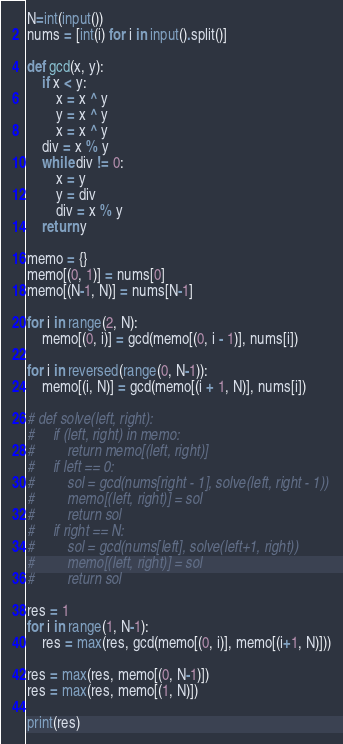Convert code to text. <code><loc_0><loc_0><loc_500><loc_500><_Python_>N=int(input())
nums = [int(i) for i in input().split()]

def gcd(x, y):
    if x < y:
        x = x ^ y
        y = x ^ y
        x = x ^ y
    div = x % y
    while div != 0:
        x = y
        y = div
        div = x % y
    return y

memo = {}
memo[(0, 1)] = nums[0]
memo[(N-1, N)] = nums[N-1]

for i in range(2, N):
    memo[(0, i)] = gcd(memo[(0, i - 1)], nums[i])

for i in reversed(range(0, N-1)):
    memo[(i, N)] = gcd(memo[(i + 1, N)], nums[i])

# def solve(left, right):
#     if (left, right) in memo:
#         return memo[(left, right)]
#     if left == 0:
#         sol = gcd(nums[right - 1], solve(left, right - 1))
#         memo[(left, right)] = sol
#         return sol
#     if right == N:
#         sol = gcd(nums[left], solve(left+1, right))
#         memo[(left, right)] = sol
#         return sol

res = 1
for i in range(1, N-1):
    res = max(res, gcd(memo[(0, i)], memo[(i+1, N)]))

res = max(res, memo[(0, N-1)])
res = max(res, memo[(1, N)])

print(res)
</code> 